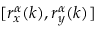<formula> <loc_0><loc_0><loc_500><loc_500>[ r _ { x } ^ { \alpha } ( k ) , r _ { y } ^ { \alpha } ( k ) ]</formula> 